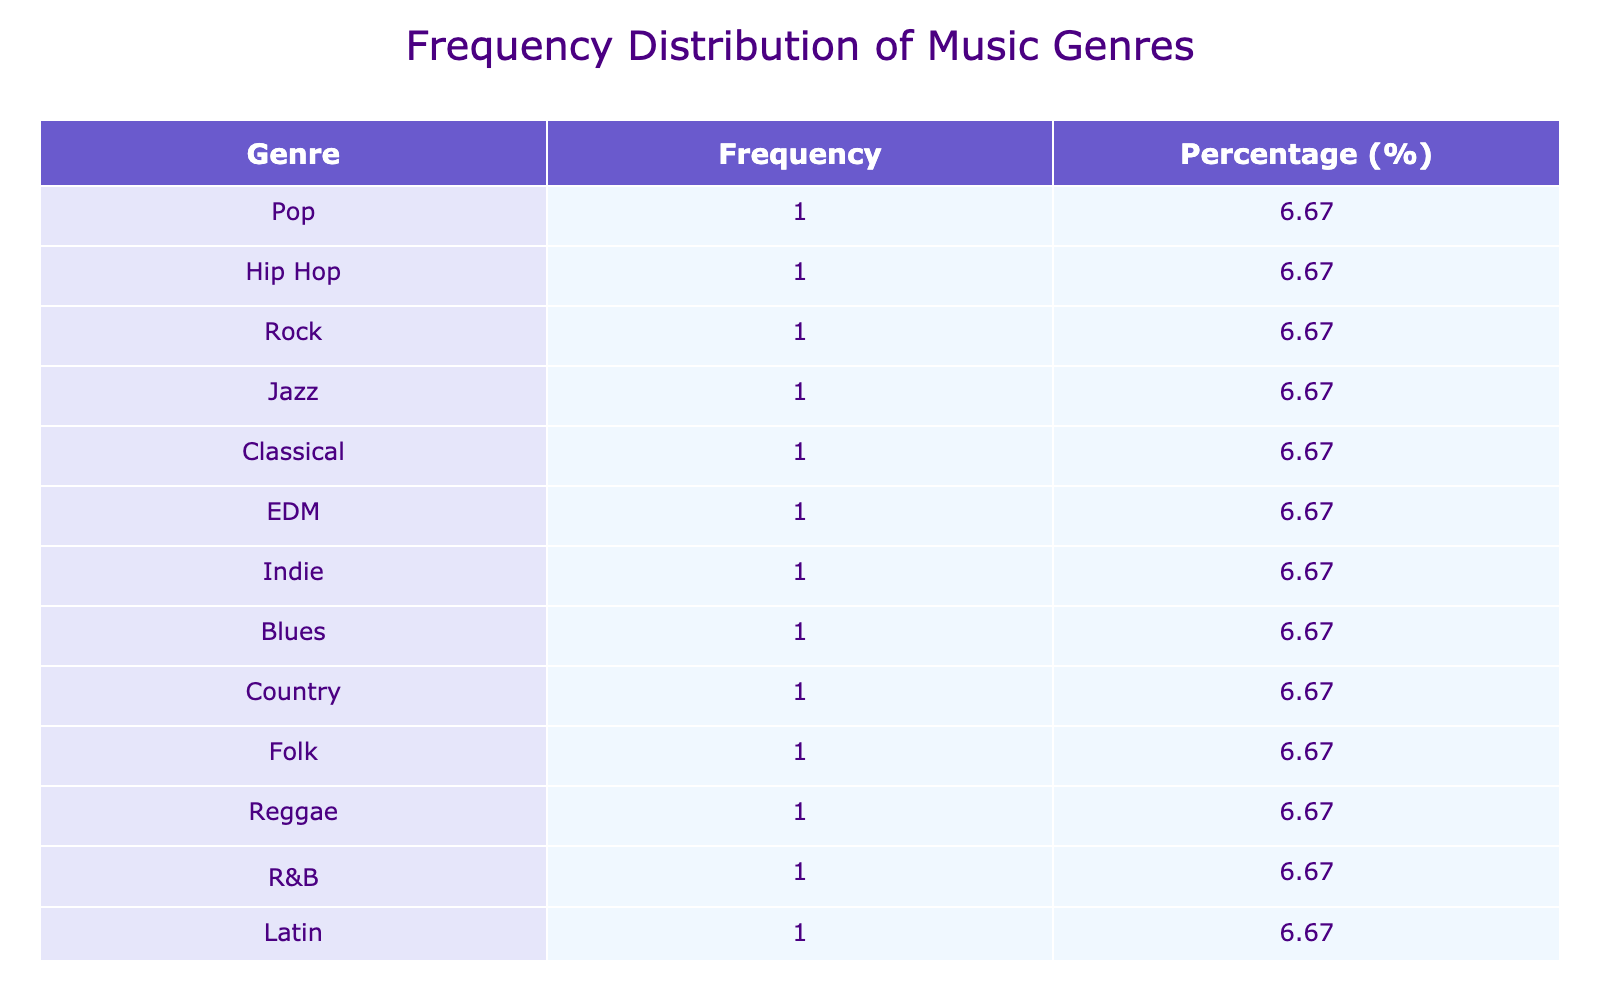What genre has the highest frequency of listeners? Looking at the frequency distribution table, I can see that the genre with the highest listener count is Hip Hop, which has 4200 listeners.
Answer: Hip Hop How many listeners prefer Pop and EDM combined? The table shows that Pop has 3500 listeners and EDM has 3000 listeners. I can sum these two values: 3500 + 3000 = 6500.
Answer: 6500 Is there more interest in Rock than in Jazz? The table lists Rock with 2900 listeners and Jazz with 1800 listeners. Since 2900 is greater than 1800, this indicates that there is indeed more interest in Rock than in Jazz.
Answer: Yes What is the percentage of listeners who prefer Classical music? The table indicates that Classical music has 1600 listeners. To find the percentage, I divide 1600 by the total listeners (which sums to 20900) and multiply by 100: (1600 / 20900) * 100 ≈ 7.66%.
Answer: 7.66% What are the total listeners in the age group of 45-54, and how does it compare to the 18-24 age group? By examining the table, 45-54 has Jazz (1800), Blues (1200), and Alternative (2000), which totals: 1800 + 1200 + 2000 = 5000 listeners. The 18-24 group has Pop (3500), EDM (3000), and Reggae (1600), totaling: 3500 + 3000 + 1600 = 8100 listeners. Comparing the two totals, 8100 is greater than 5000, indicating that the 18-24 age group has more listeners in total.
Answer: The 18-24 age group has more listeners Are there any genres preferred primarily by females? By reviewing the table, Pop (3500), Rock (2900), Classical (1600), Country (2700), and Folk (1400) are all preferred by females. This confirms that there are several genres preferred primarily by females.
Answer: Yes 